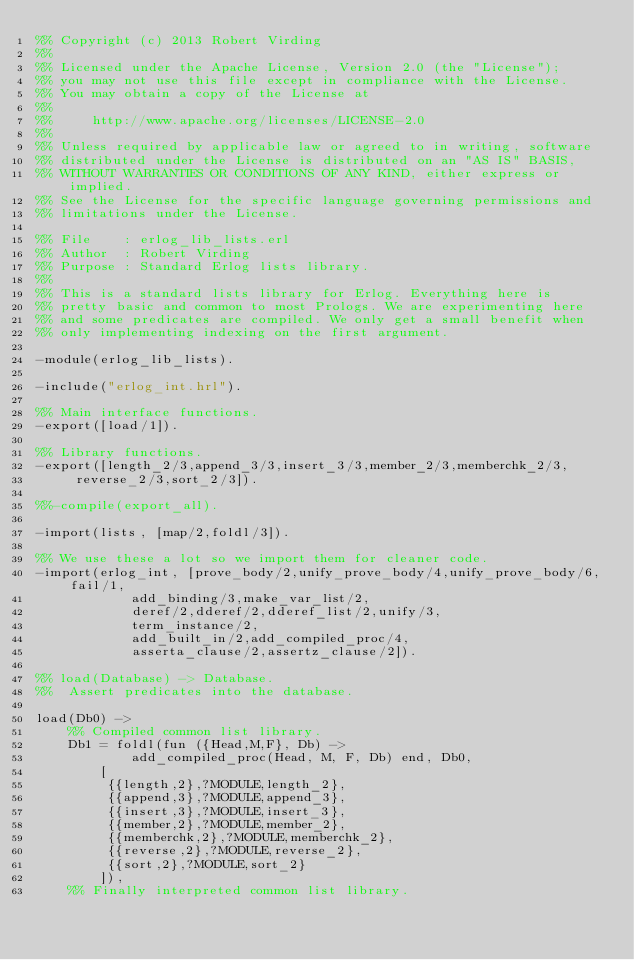<code> <loc_0><loc_0><loc_500><loc_500><_Erlang_>%% Copyright (c) 2013 Robert Virding
%%
%% Licensed under the Apache License, Version 2.0 (the "License");
%% you may not use this file except in compliance with the License.
%% You may obtain a copy of the License at
%%
%%     http://www.apache.org/licenses/LICENSE-2.0
%%
%% Unless required by applicable law or agreed to in writing, software
%% distributed under the License is distributed on an "AS IS" BASIS,
%% WITHOUT WARRANTIES OR CONDITIONS OF ANY KIND, either express or implied.
%% See the License for the specific language governing permissions and
%% limitations under the License.

%% File    : erlog_lib_lists.erl
%% Author  : Robert Virding
%% Purpose : Standard Erlog lists library.
%% 
%% This is a standard lists library for Erlog. Everything here is
%% pretty basic and common to most Prologs. We are experimenting here
%% and some predicates are compiled. We only get a small benefit when
%% only implementing indexing on the first argument.

-module(erlog_lib_lists).

-include("erlog_int.hrl").

%% Main interface functions.
-export([load/1]).

%% Library functions.
-export([length_2/3,append_3/3,insert_3/3,member_2/3,memberchk_2/3,
	 reverse_2/3,sort_2/3]).

%%-compile(export_all).

-import(lists, [map/2,foldl/3]).

%% We use these a lot so we import them for cleaner code.
-import(erlog_int, [prove_body/2,unify_prove_body/4,unify_prove_body/6,fail/1,
		    add_binding/3,make_var_list/2,
		    deref/2,dderef/2,dderef_list/2,unify/3,
		    term_instance/2,
		    add_built_in/2,add_compiled_proc/4,
		    asserta_clause/2,assertz_clause/2]).

%% load(Database) -> Database.
%%  Assert predicates into the database.

load(Db0) ->
    %% Compiled common list library.
    Db1 = foldl(fun ({Head,M,F}, Db) ->
			add_compiled_proc(Head, M, F, Db) end, Db0,
		[
		 {{length,2},?MODULE,length_2},
		 {{append,3},?MODULE,append_3},
		 {{insert,3},?MODULE,insert_3},
		 {{member,2},?MODULE,member_2},
		 {{memberchk,2},?MODULE,memberchk_2},
		 {{reverse,2},?MODULE,reverse_2},
		 {{sort,2},?MODULE,sort_2}
		]),
    %% Finally interpreted common list library.</code> 